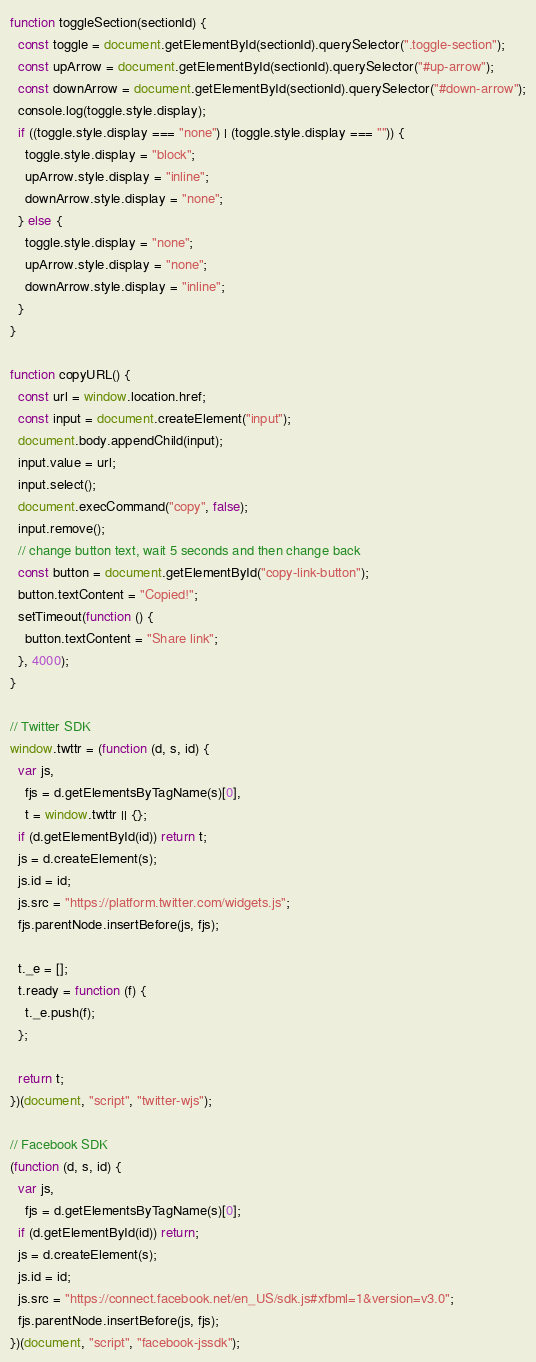<code> <loc_0><loc_0><loc_500><loc_500><_JavaScript_>function toggleSection(sectionId) {
  const toggle = document.getElementById(sectionId).querySelector(".toggle-section");
  const upArrow = document.getElementById(sectionId).querySelector("#up-arrow");
  const downArrow = document.getElementById(sectionId).querySelector("#down-arrow");
  console.log(toggle.style.display);
  if ((toggle.style.display === "none") | (toggle.style.display === "")) {
    toggle.style.display = "block";
    upArrow.style.display = "inline";
    downArrow.style.display = "none";
  } else {
    toggle.style.display = "none";
    upArrow.style.display = "none";
    downArrow.style.display = "inline";
  }
}

function copyURL() {
  const url = window.location.href;
  const input = document.createElement("input");
  document.body.appendChild(input);
  input.value = url;
  input.select();
  document.execCommand("copy", false);
  input.remove();
  // change button text, wait 5 seconds and then change back
  const button = document.getElementById("copy-link-button");
  button.textContent = "Copied!";
  setTimeout(function () {
    button.textContent = "Share link";
  }, 4000);
}

// Twitter SDK
window.twttr = (function (d, s, id) {
  var js,
    fjs = d.getElementsByTagName(s)[0],
    t = window.twttr || {};
  if (d.getElementById(id)) return t;
  js = d.createElement(s);
  js.id = id;
  js.src = "https://platform.twitter.com/widgets.js";
  fjs.parentNode.insertBefore(js, fjs);

  t._e = [];
  t.ready = function (f) {
    t._e.push(f);
  };

  return t;
})(document, "script", "twitter-wjs");

// Facebook SDK
(function (d, s, id) {
  var js,
    fjs = d.getElementsByTagName(s)[0];
  if (d.getElementById(id)) return;
  js = d.createElement(s);
  js.id = id;
  js.src = "https://connect.facebook.net/en_US/sdk.js#xfbml=1&version=v3.0";
  fjs.parentNode.insertBefore(js, fjs);
})(document, "script", "facebook-jssdk");
</code> 